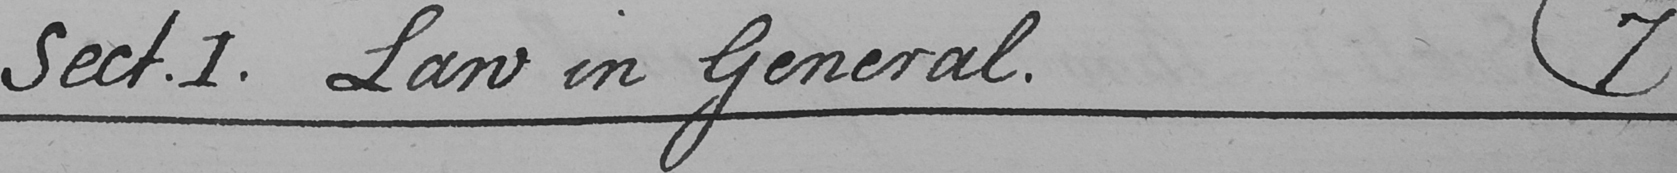What does this handwritten line say? Sect . I . Law in General .  ( 7 